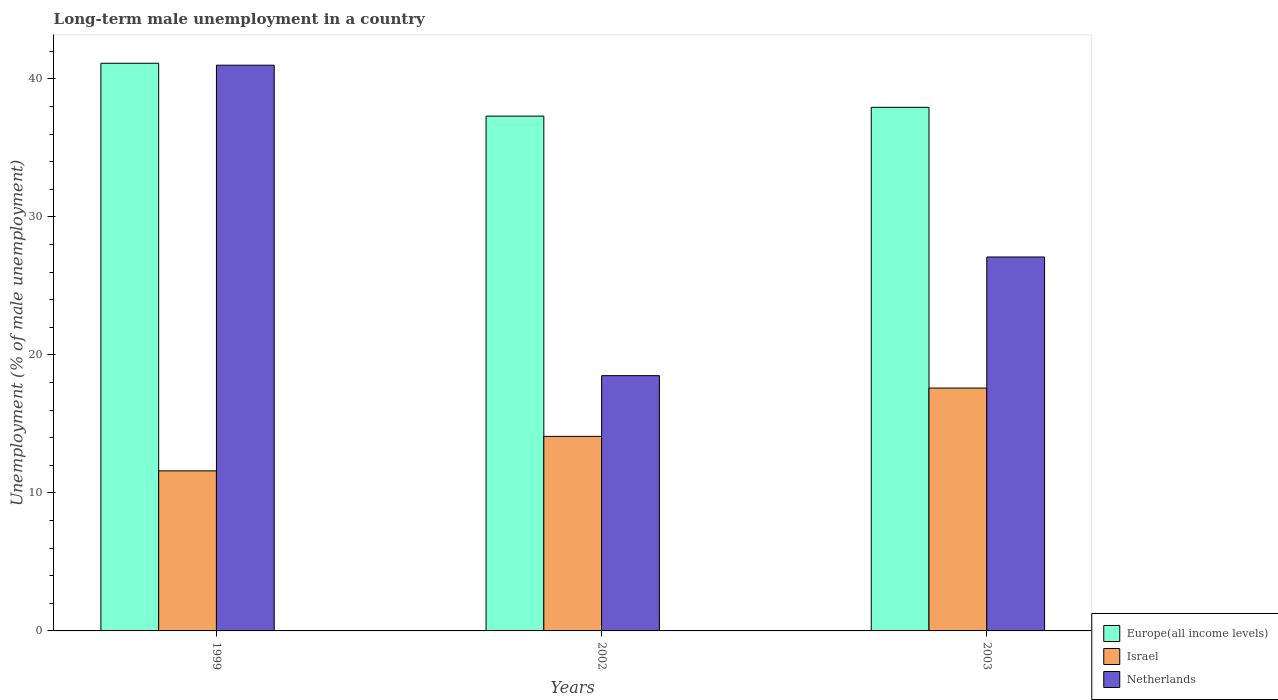How many different coloured bars are there?
Offer a very short reply. 3. Are the number of bars per tick equal to the number of legend labels?
Offer a terse response. Yes. How many bars are there on the 2nd tick from the left?
Offer a very short reply. 3. What is the label of the 3rd group of bars from the left?
Ensure brevity in your answer.  2003. In how many cases, is the number of bars for a given year not equal to the number of legend labels?
Give a very brief answer. 0. What is the percentage of long-term unemployed male population in Netherlands in 2003?
Provide a succinct answer. 27.1. Across all years, what is the maximum percentage of long-term unemployed male population in Israel?
Keep it short and to the point. 17.6. Across all years, what is the minimum percentage of long-term unemployed male population in Israel?
Ensure brevity in your answer.  11.6. What is the total percentage of long-term unemployed male population in Europe(all income levels) in the graph?
Offer a very short reply. 116.4. What is the difference between the percentage of long-term unemployed male population in Europe(all income levels) in 1999 and that in 2002?
Provide a succinct answer. 3.83. What is the difference between the percentage of long-term unemployed male population in Israel in 2003 and the percentage of long-term unemployed male population in Europe(all income levels) in 2002?
Your response must be concise. -19.71. What is the average percentage of long-term unemployed male population in Netherlands per year?
Your answer should be very brief. 28.87. In the year 1999, what is the difference between the percentage of long-term unemployed male population in Netherlands and percentage of long-term unemployed male population in Israel?
Your response must be concise. 29.4. In how many years, is the percentage of long-term unemployed male population in Netherlands greater than 32 %?
Your answer should be very brief. 1. What is the ratio of the percentage of long-term unemployed male population in Europe(all income levels) in 1999 to that in 2003?
Provide a short and direct response. 1.08. Is the percentage of long-term unemployed male population in Netherlands in 2002 less than that in 2003?
Keep it short and to the point. Yes. What is the difference between the highest and the second highest percentage of long-term unemployed male population in Israel?
Keep it short and to the point. 3.5. What is the difference between the highest and the lowest percentage of long-term unemployed male population in Netherlands?
Provide a succinct answer. 22.5. In how many years, is the percentage of long-term unemployed male population in Europe(all income levels) greater than the average percentage of long-term unemployed male population in Europe(all income levels) taken over all years?
Ensure brevity in your answer.  1. What does the 1st bar from the left in 2003 represents?
Your answer should be compact. Europe(all income levels). How many bars are there?
Keep it short and to the point. 9. Are all the bars in the graph horizontal?
Your answer should be very brief. No. What is the difference between two consecutive major ticks on the Y-axis?
Provide a short and direct response. 10. Are the values on the major ticks of Y-axis written in scientific E-notation?
Your response must be concise. No. Does the graph contain any zero values?
Offer a terse response. No. Does the graph contain grids?
Your response must be concise. No. How many legend labels are there?
Your answer should be very brief. 3. How are the legend labels stacked?
Ensure brevity in your answer.  Vertical. What is the title of the graph?
Offer a terse response. Long-term male unemployment in a country. What is the label or title of the Y-axis?
Your response must be concise. Unemployment (% of male unemployment). What is the Unemployment (% of male unemployment) of Europe(all income levels) in 1999?
Give a very brief answer. 41.14. What is the Unemployment (% of male unemployment) of Israel in 1999?
Offer a terse response. 11.6. What is the Unemployment (% of male unemployment) of Europe(all income levels) in 2002?
Ensure brevity in your answer.  37.31. What is the Unemployment (% of male unemployment) in Israel in 2002?
Make the answer very short. 14.1. What is the Unemployment (% of male unemployment) in Netherlands in 2002?
Keep it short and to the point. 18.5. What is the Unemployment (% of male unemployment) in Europe(all income levels) in 2003?
Your answer should be compact. 37.95. What is the Unemployment (% of male unemployment) of Israel in 2003?
Provide a short and direct response. 17.6. What is the Unemployment (% of male unemployment) of Netherlands in 2003?
Provide a succinct answer. 27.1. Across all years, what is the maximum Unemployment (% of male unemployment) in Europe(all income levels)?
Keep it short and to the point. 41.14. Across all years, what is the maximum Unemployment (% of male unemployment) in Israel?
Give a very brief answer. 17.6. Across all years, what is the maximum Unemployment (% of male unemployment) in Netherlands?
Provide a short and direct response. 41. Across all years, what is the minimum Unemployment (% of male unemployment) of Europe(all income levels)?
Ensure brevity in your answer.  37.31. Across all years, what is the minimum Unemployment (% of male unemployment) of Israel?
Provide a short and direct response. 11.6. Across all years, what is the minimum Unemployment (% of male unemployment) of Netherlands?
Your answer should be very brief. 18.5. What is the total Unemployment (% of male unemployment) in Europe(all income levels) in the graph?
Provide a succinct answer. 116.4. What is the total Unemployment (% of male unemployment) in Israel in the graph?
Make the answer very short. 43.3. What is the total Unemployment (% of male unemployment) in Netherlands in the graph?
Make the answer very short. 86.6. What is the difference between the Unemployment (% of male unemployment) of Europe(all income levels) in 1999 and that in 2002?
Keep it short and to the point. 3.83. What is the difference between the Unemployment (% of male unemployment) in Israel in 1999 and that in 2002?
Provide a short and direct response. -2.5. What is the difference between the Unemployment (% of male unemployment) of Europe(all income levels) in 1999 and that in 2003?
Your answer should be very brief. 3.19. What is the difference between the Unemployment (% of male unemployment) in Israel in 1999 and that in 2003?
Offer a terse response. -6. What is the difference between the Unemployment (% of male unemployment) in Netherlands in 1999 and that in 2003?
Offer a very short reply. 13.9. What is the difference between the Unemployment (% of male unemployment) in Europe(all income levels) in 2002 and that in 2003?
Offer a very short reply. -0.64. What is the difference between the Unemployment (% of male unemployment) in Israel in 2002 and that in 2003?
Ensure brevity in your answer.  -3.5. What is the difference between the Unemployment (% of male unemployment) of Europe(all income levels) in 1999 and the Unemployment (% of male unemployment) of Israel in 2002?
Provide a short and direct response. 27.04. What is the difference between the Unemployment (% of male unemployment) of Europe(all income levels) in 1999 and the Unemployment (% of male unemployment) of Netherlands in 2002?
Your answer should be compact. 22.64. What is the difference between the Unemployment (% of male unemployment) of Europe(all income levels) in 1999 and the Unemployment (% of male unemployment) of Israel in 2003?
Your answer should be compact. 23.54. What is the difference between the Unemployment (% of male unemployment) in Europe(all income levels) in 1999 and the Unemployment (% of male unemployment) in Netherlands in 2003?
Give a very brief answer. 14.04. What is the difference between the Unemployment (% of male unemployment) in Israel in 1999 and the Unemployment (% of male unemployment) in Netherlands in 2003?
Provide a succinct answer. -15.5. What is the difference between the Unemployment (% of male unemployment) in Europe(all income levels) in 2002 and the Unemployment (% of male unemployment) in Israel in 2003?
Your answer should be compact. 19.71. What is the difference between the Unemployment (% of male unemployment) in Europe(all income levels) in 2002 and the Unemployment (% of male unemployment) in Netherlands in 2003?
Your response must be concise. 10.21. What is the difference between the Unemployment (% of male unemployment) in Israel in 2002 and the Unemployment (% of male unemployment) in Netherlands in 2003?
Offer a terse response. -13. What is the average Unemployment (% of male unemployment) of Europe(all income levels) per year?
Offer a very short reply. 38.8. What is the average Unemployment (% of male unemployment) in Israel per year?
Your answer should be compact. 14.43. What is the average Unemployment (% of male unemployment) of Netherlands per year?
Your answer should be very brief. 28.87. In the year 1999, what is the difference between the Unemployment (% of male unemployment) of Europe(all income levels) and Unemployment (% of male unemployment) of Israel?
Keep it short and to the point. 29.54. In the year 1999, what is the difference between the Unemployment (% of male unemployment) in Europe(all income levels) and Unemployment (% of male unemployment) in Netherlands?
Provide a short and direct response. 0.14. In the year 1999, what is the difference between the Unemployment (% of male unemployment) in Israel and Unemployment (% of male unemployment) in Netherlands?
Offer a very short reply. -29.4. In the year 2002, what is the difference between the Unemployment (% of male unemployment) of Europe(all income levels) and Unemployment (% of male unemployment) of Israel?
Offer a very short reply. 23.21. In the year 2002, what is the difference between the Unemployment (% of male unemployment) of Europe(all income levels) and Unemployment (% of male unemployment) of Netherlands?
Offer a terse response. 18.81. In the year 2002, what is the difference between the Unemployment (% of male unemployment) of Israel and Unemployment (% of male unemployment) of Netherlands?
Offer a terse response. -4.4. In the year 2003, what is the difference between the Unemployment (% of male unemployment) in Europe(all income levels) and Unemployment (% of male unemployment) in Israel?
Offer a terse response. 20.35. In the year 2003, what is the difference between the Unemployment (% of male unemployment) in Europe(all income levels) and Unemployment (% of male unemployment) in Netherlands?
Ensure brevity in your answer.  10.85. What is the ratio of the Unemployment (% of male unemployment) in Europe(all income levels) in 1999 to that in 2002?
Your answer should be compact. 1.1. What is the ratio of the Unemployment (% of male unemployment) in Israel in 1999 to that in 2002?
Offer a terse response. 0.82. What is the ratio of the Unemployment (% of male unemployment) in Netherlands in 1999 to that in 2002?
Your response must be concise. 2.22. What is the ratio of the Unemployment (% of male unemployment) in Europe(all income levels) in 1999 to that in 2003?
Keep it short and to the point. 1.08. What is the ratio of the Unemployment (% of male unemployment) in Israel in 1999 to that in 2003?
Keep it short and to the point. 0.66. What is the ratio of the Unemployment (% of male unemployment) of Netherlands in 1999 to that in 2003?
Keep it short and to the point. 1.51. What is the ratio of the Unemployment (% of male unemployment) in Europe(all income levels) in 2002 to that in 2003?
Give a very brief answer. 0.98. What is the ratio of the Unemployment (% of male unemployment) in Israel in 2002 to that in 2003?
Your answer should be compact. 0.8. What is the ratio of the Unemployment (% of male unemployment) of Netherlands in 2002 to that in 2003?
Provide a short and direct response. 0.68. What is the difference between the highest and the second highest Unemployment (% of male unemployment) in Europe(all income levels)?
Your answer should be very brief. 3.19. What is the difference between the highest and the lowest Unemployment (% of male unemployment) in Europe(all income levels)?
Your response must be concise. 3.83. What is the difference between the highest and the lowest Unemployment (% of male unemployment) in Israel?
Offer a terse response. 6. What is the difference between the highest and the lowest Unemployment (% of male unemployment) in Netherlands?
Keep it short and to the point. 22.5. 